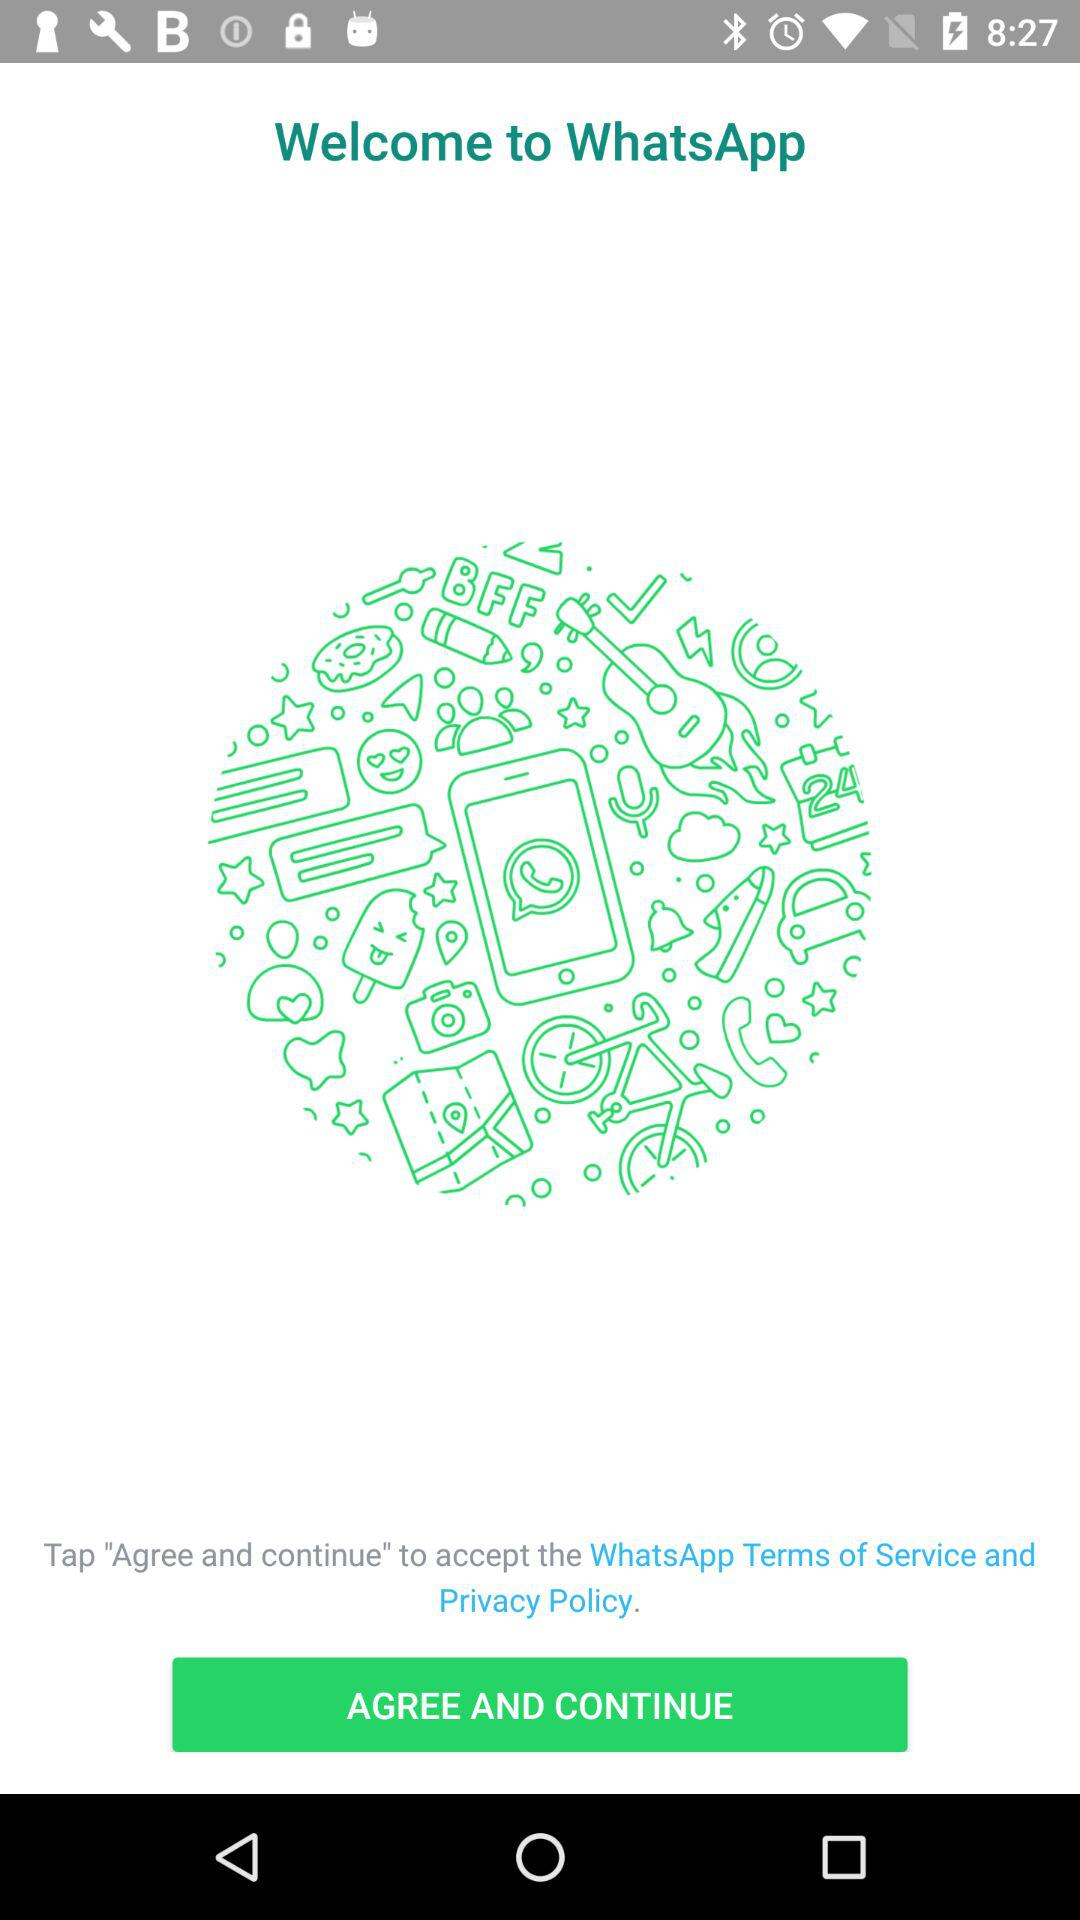What is the name of the application? The name of the application is "WhatsApp". 